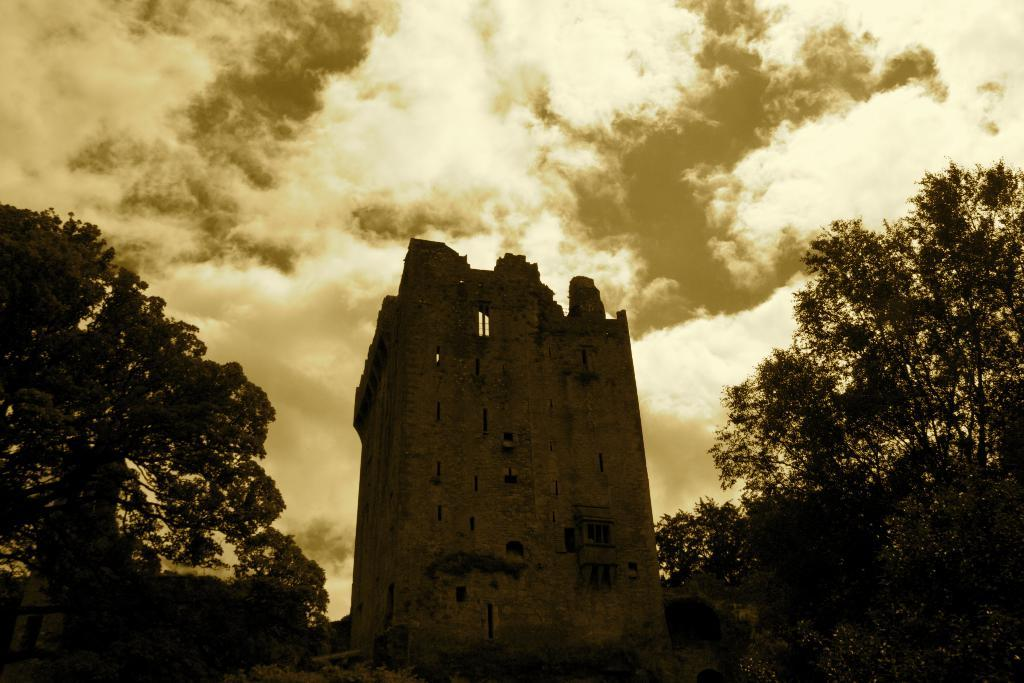What type of structure is present in the image? There is a building in the image. What are the main features of the building? The building has walls and windows. What else can be seen in the image besides the building? There are many trees in the image. What is visible at the top of the image? The sky is visible at the top of the image. What can be observed about the sky in the image? There are clouds in the sky. How far does the duck run in the image? There is no duck present in the image, and therefore no running duck can be observed. 